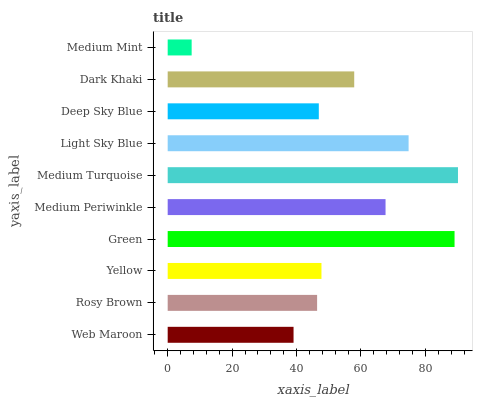Is Medium Mint the minimum?
Answer yes or no. Yes. Is Medium Turquoise the maximum?
Answer yes or no. Yes. Is Rosy Brown the minimum?
Answer yes or no. No. Is Rosy Brown the maximum?
Answer yes or no. No. Is Rosy Brown greater than Web Maroon?
Answer yes or no. Yes. Is Web Maroon less than Rosy Brown?
Answer yes or no. Yes. Is Web Maroon greater than Rosy Brown?
Answer yes or no. No. Is Rosy Brown less than Web Maroon?
Answer yes or no. No. Is Dark Khaki the high median?
Answer yes or no. Yes. Is Yellow the low median?
Answer yes or no. Yes. Is Light Sky Blue the high median?
Answer yes or no. No. Is Dark Khaki the low median?
Answer yes or no. No. 